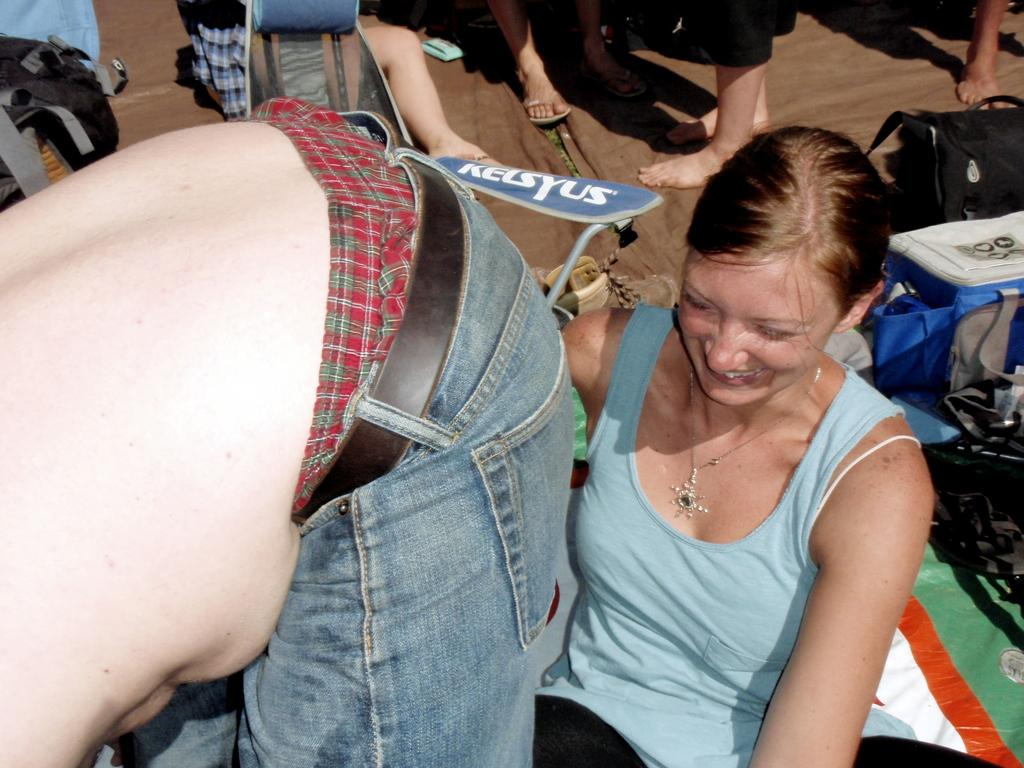Who or what is present in the image? There are people in the image. Can you describe the appearance of the people? The people are wearing different color dresses. What else can be seen in the image besides the people? There are many bags in the image. On what surface are the bags placed? The bags are on a brown color surface. What book is the beetle reading in the image? There is no beetle or book present in the image. 